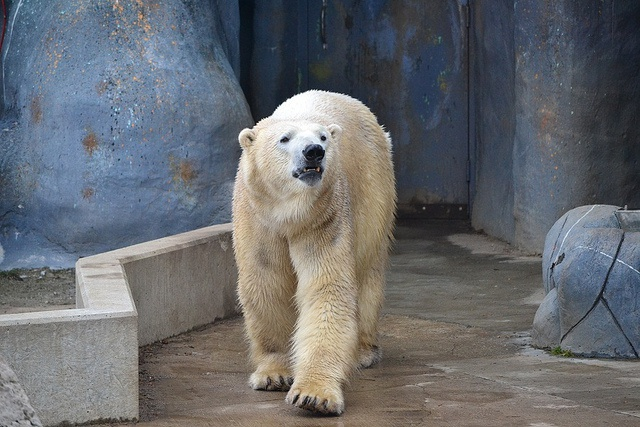Describe the objects in this image and their specific colors. I can see a bear in black, darkgray, gray, and lightgray tones in this image. 